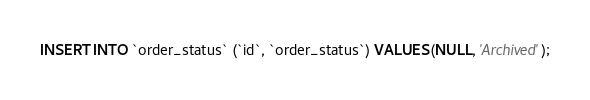<code> <loc_0><loc_0><loc_500><loc_500><_SQL_>INSERT INTO `order_status` (`id`, `order_status`) VALUES (NULL, 'Archived');</code> 